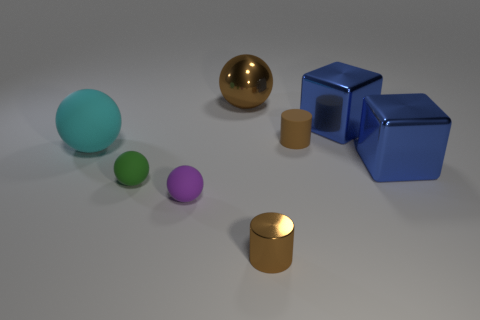There is another small cylinder that is the same color as the matte cylinder; what is it made of? The small cylinder that shares the color with the matte cylinder could also be made of a variety of materials, such as plastic, ceramics, or metals including aluminum or brass. Without specific details on its texture, weight and context, we can't definitively conclude its composition just by color alone. 